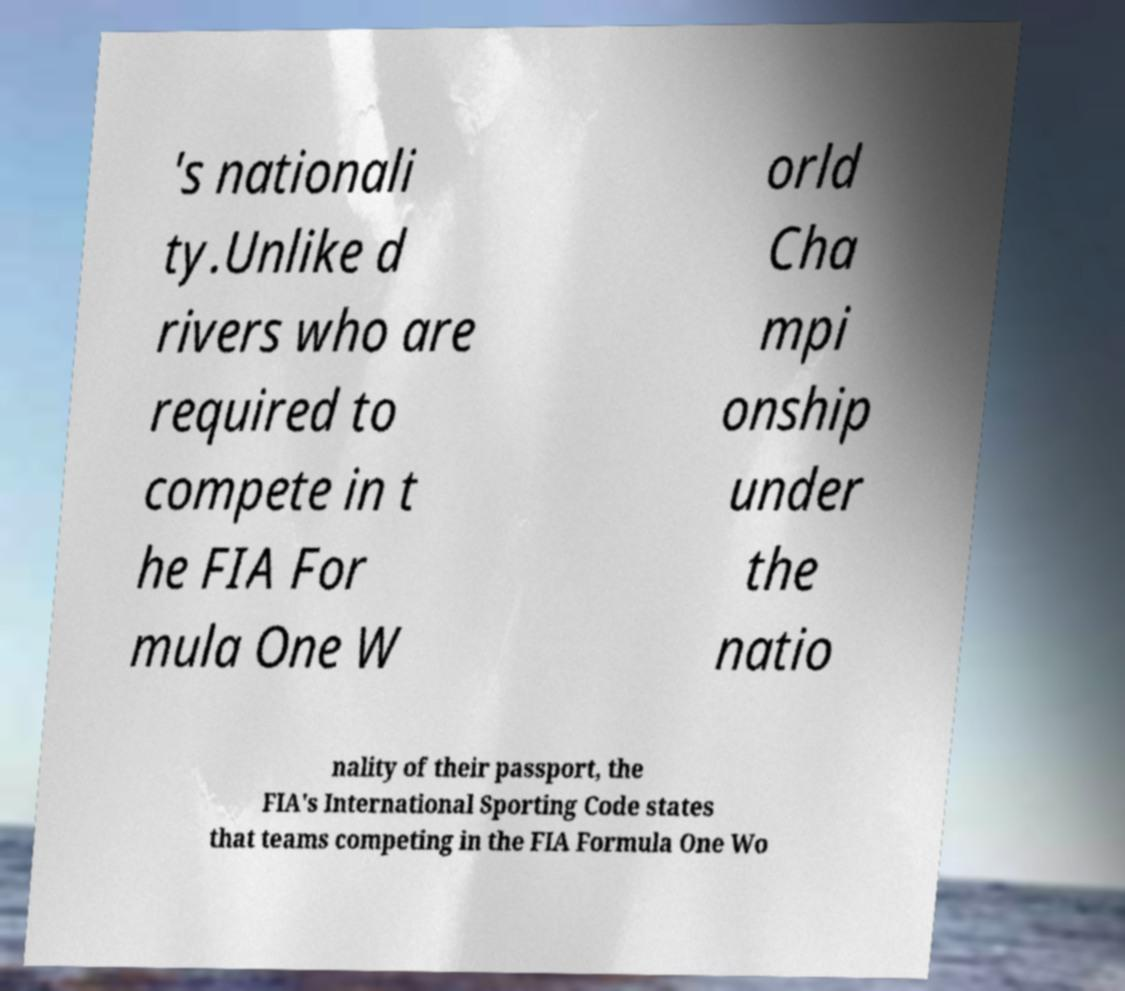I need the written content from this picture converted into text. Can you do that? 's nationali ty.Unlike d rivers who are required to compete in t he FIA For mula One W orld Cha mpi onship under the natio nality of their passport, the FIA's International Sporting Code states that teams competing in the FIA Formula One Wo 